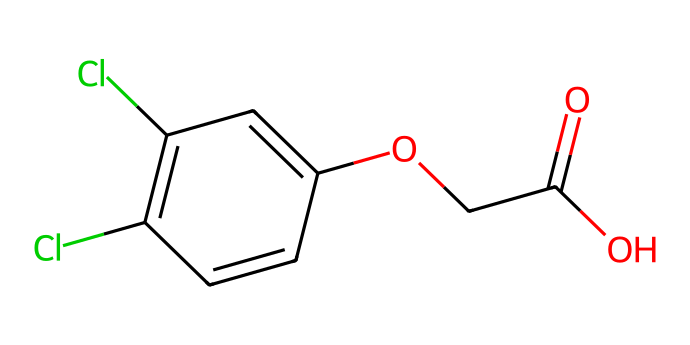What is the molecular formula of 2,4-D? From the structural representation, we can identify the number of carbon (C), hydrogen (H), oxygen (O), and chlorine (Cl) atoms present. The structure shows 8 carbons, 8 hydrogens, 2 oxygens, and 2 chlorines. Thus, the molecular formula is C8H6Cl2O3.
Answer: C8H6Cl2O3 How many rings does 2,4-D contain? Observing the structure, we see that there is one distinctive ring formed by the carbon atoms. The benzene-like structure consists of alternating double bonds in a cyclic arrangement, indicating a single ring.
Answer: 1 What functional groups are present in 2,4-D? Analyzing the structure, we can spot multiple functional groups. The presence of the carboxylic acid (-COOH) group and the ether (–O–) linkage indicates that these are the main functional groups in the compound.
Answer: carboxylic acid, ether How many chlorine atoms are in 2,4-D? The structure explicitly reveals two chlorine (Cl) atoms attached to the phenoxy portion of the molecule. This can be determined by counting the Cl atoms in the representation.
Answer: 2 What is the primary role of 2,4-D as a herbicide? Understanding the mode of action of this herbicide reveals that it mimics plant hormones known as auxins, leading to abnormal growth and eventually plant death. Thus, its main role is to control broadleaf weeds in lawns and crops.
Answer: mimic plant hormones What impact does the presence of chlorine atoms have on the herbicide's effectiveness? Chlorine atoms can enhance the lipophilicity of the molecule, which may improve its absorption by plant tissues, thereby increasing its effectiveness as a selective herbicide against broadleaf plants.
Answer: increase effectiveness What type of herbicide is 2,4-D classified as? 2,4-D is classified as a systemic herbicide, which means it is absorbed and translocated within the plant to control growth. This property allows it to be effective against a wide range of weeds.
Answer: systemic herbicide 